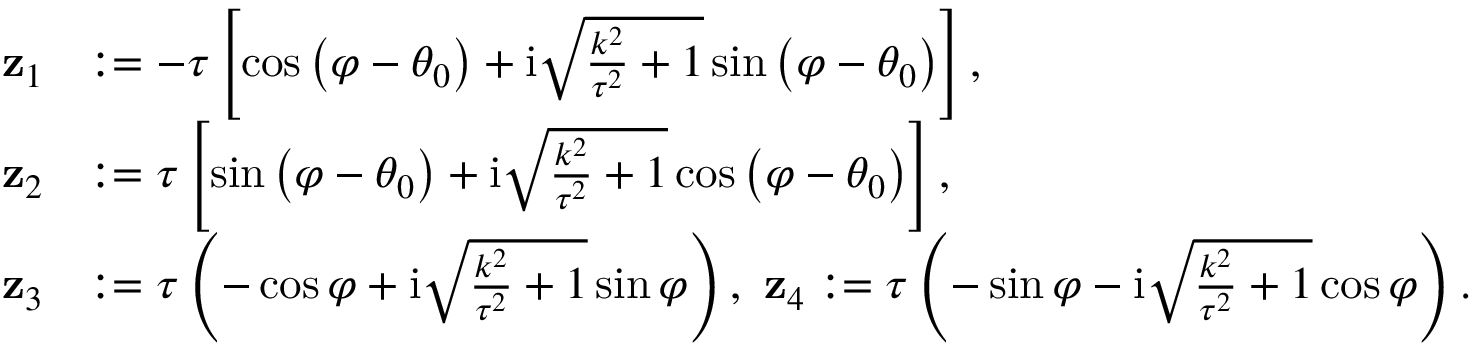<formula> <loc_0><loc_0><loc_500><loc_500>\begin{array} { r l } { \mathbf z _ { 1 } } & { \colon = - \tau \left [ \cos \left ( \varphi - \theta _ { 0 } \right ) + i \sqrt { \frac { k ^ { 2 } } { \tau ^ { 2 } } + 1 } \sin \left ( \varphi - \theta _ { 0 } \right ) \right ] , } \\ { \mathbf z _ { 2 } } & { \colon = \tau \left [ \sin \left ( \varphi - \theta _ { 0 } \right ) + i \sqrt { \frac { k ^ { 2 } } { \tau ^ { 2 } } + 1 } \cos \left ( \varphi - \theta _ { 0 } \right ) \right ] , } \\ { \mathbf z _ { 3 } } & { \colon = \tau \left ( - \cos \varphi + \mathrm i \sqrt { \frac { k ^ { 2 } } { \tau ^ { 2 } } + 1 } \sin \varphi \right ) , \ \mathbf z _ { 4 } \colon = \tau \left ( - \sin \varphi - \mathrm i \sqrt { \frac { k ^ { 2 } } { \tau ^ { 2 } } + 1 } \cos \varphi \right ) . } \end{array}</formula> 